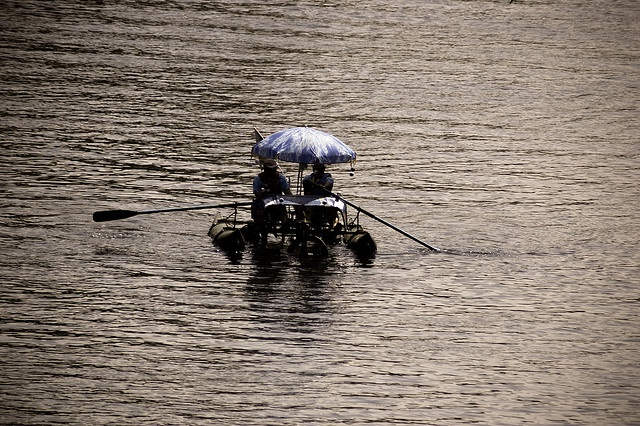Describe the objects in this image and their specific colors. I can see boat in black, gray, darkgray, and white tones, umbrella in black, lightgray, darkgray, and gray tones, people in black and gray tones, and people in black, gray, and darkgray tones in this image. 